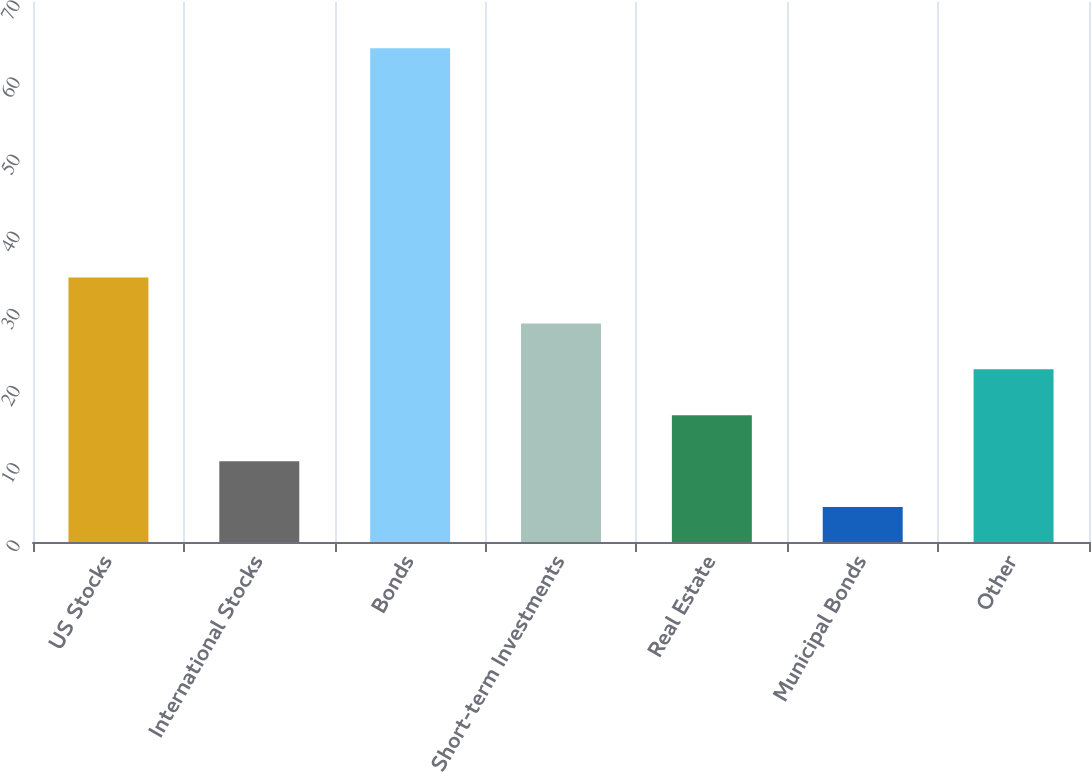Convert chart. <chart><loc_0><loc_0><loc_500><loc_500><bar_chart><fcel>US Stocks<fcel>International Stocks<fcel>Bonds<fcel>Short-term Investments<fcel>Real Estate<fcel>Municipal Bonds<fcel>Other<nl><fcel>34.28<fcel>10.48<fcel>64<fcel>28.33<fcel>16.43<fcel>4.53<fcel>22.38<nl></chart> 